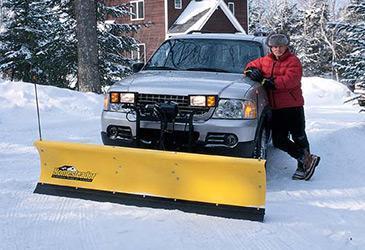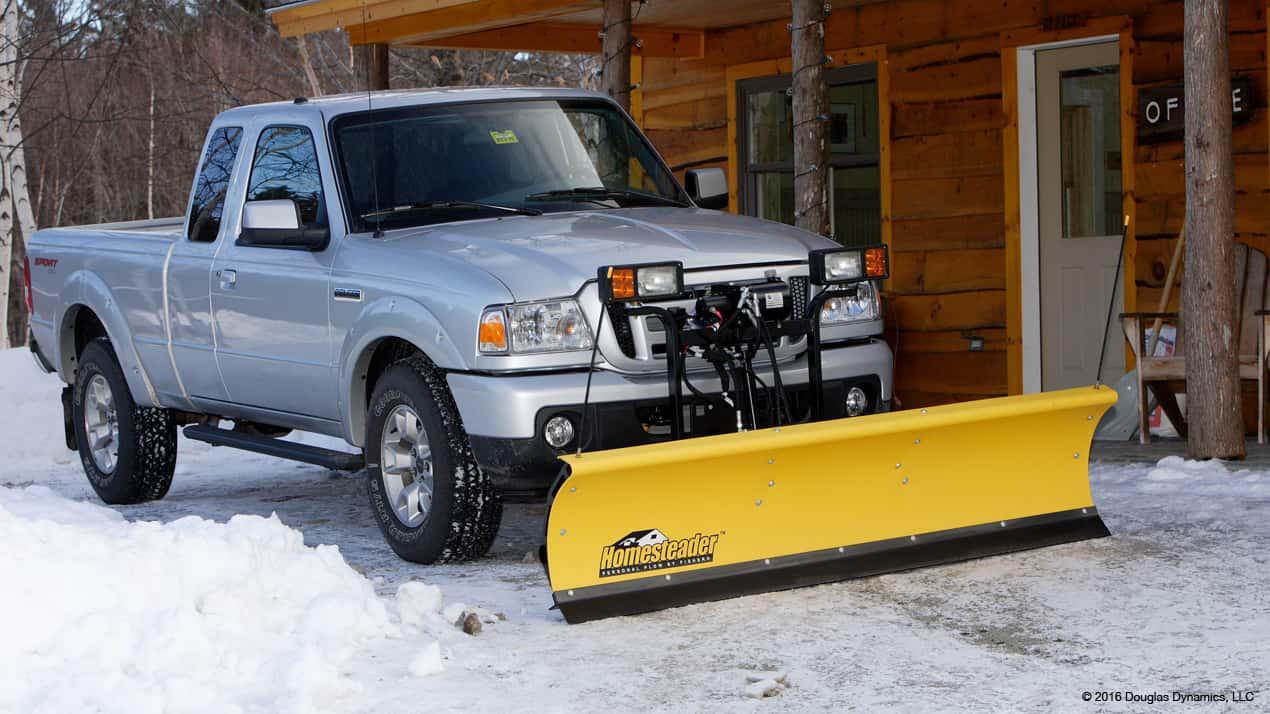The first image is the image on the left, the second image is the image on the right. Given the left and right images, does the statement "At least one snowplow is not yellow." hold true? Answer yes or no. No. 